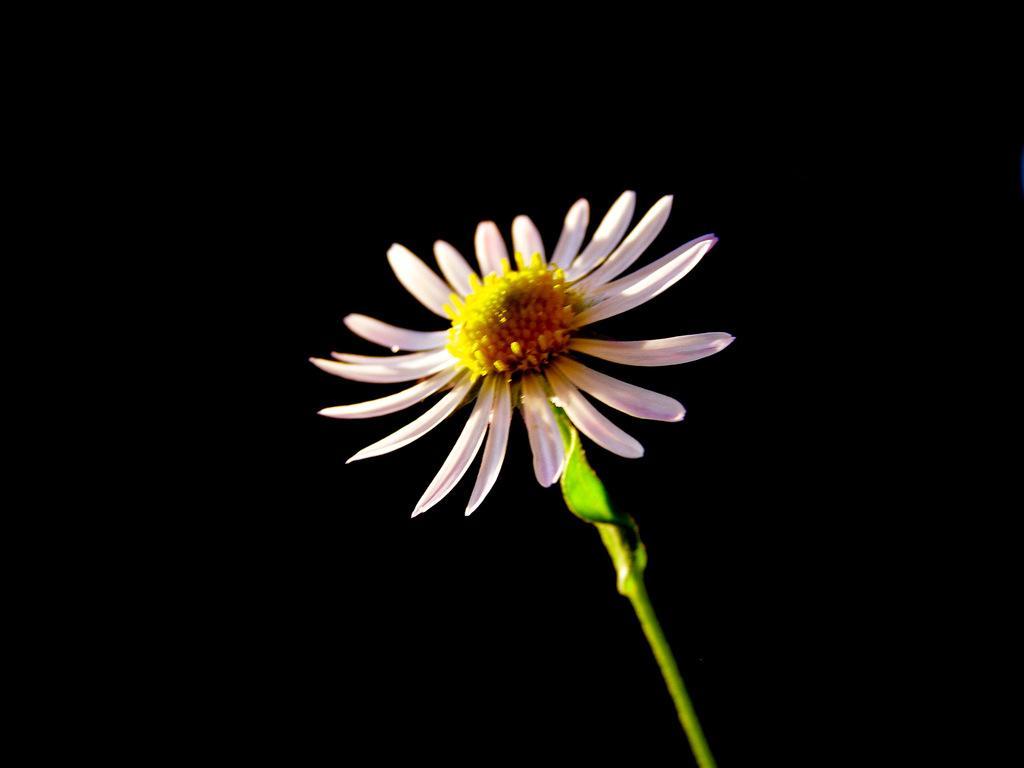Describe this image in one or two sentences. In the picture we can see a flower with a stem and the petals are light pink in color. 